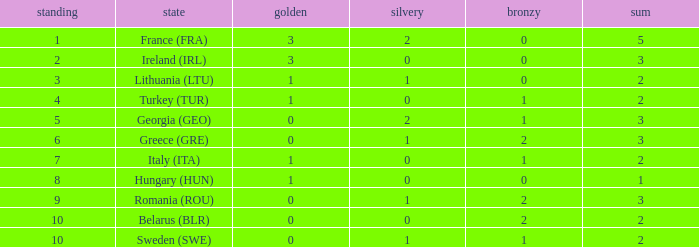Can you give me this table as a dict? {'header': ['standing', 'state', 'golden', 'silvery', 'bronzy', 'sum'], 'rows': [['1', 'France (FRA)', '3', '2', '0', '5'], ['2', 'Ireland (IRL)', '3', '0', '0', '3'], ['3', 'Lithuania (LTU)', '1', '1', '0', '2'], ['4', 'Turkey (TUR)', '1', '0', '1', '2'], ['5', 'Georgia (GEO)', '0', '2', '1', '3'], ['6', 'Greece (GRE)', '0', '1', '2', '3'], ['7', 'Italy (ITA)', '1', '0', '1', '2'], ['8', 'Hungary (HUN)', '1', '0', '0', '1'], ['9', 'Romania (ROU)', '0', '1', '2', '3'], ['10', 'Belarus (BLR)', '0', '0', '2', '2'], ['10', 'Sweden (SWE)', '0', '1', '1', '2']]} What's the total when the gold is less than 0 and silver is less than 1? None. 